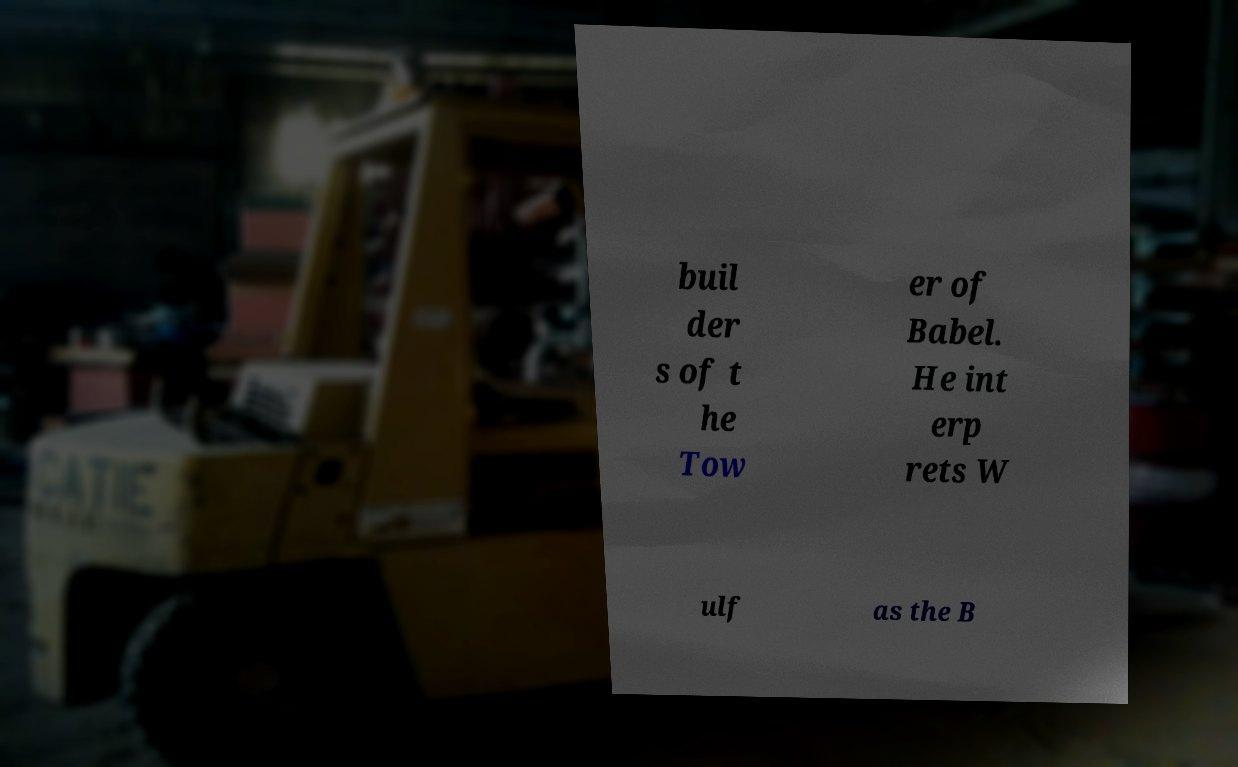Can you read and provide the text displayed in the image?This photo seems to have some interesting text. Can you extract and type it out for me? buil der s of t he Tow er of Babel. He int erp rets W ulf as the B 